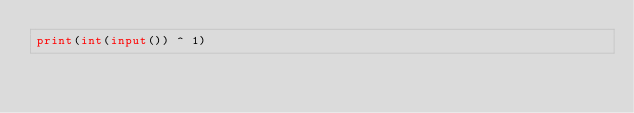Convert code to text. <code><loc_0><loc_0><loc_500><loc_500><_Python_>print(int(input()) ^ 1)
</code> 